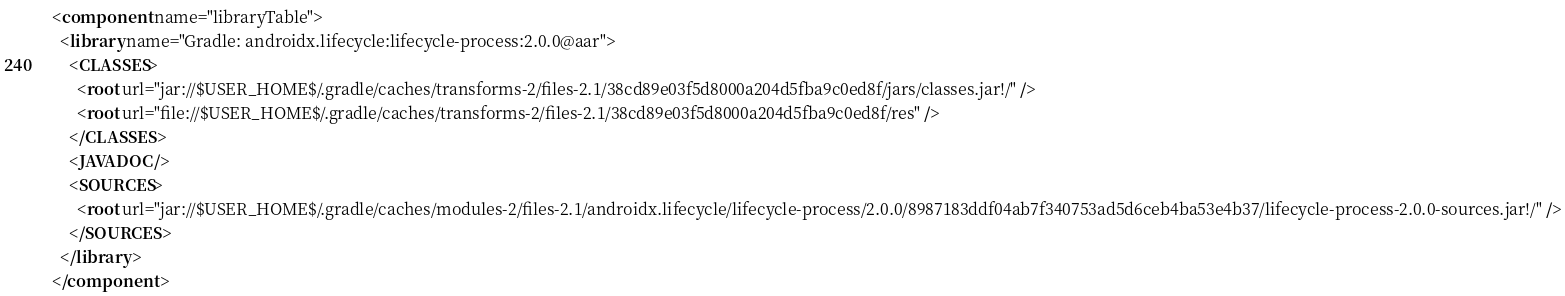Convert code to text. <code><loc_0><loc_0><loc_500><loc_500><_XML_><component name="libraryTable">
  <library name="Gradle: androidx.lifecycle:lifecycle-process:2.0.0@aar">
    <CLASSES>
      <root url="jar://$USER_HOME$/.gradle/caches/transforms-2/files-2.1/38cd89e03f5d8000a204d5fba9c0ed8f/jars/classes.jar!/" />
      <root url="file://$USER_HOME$/.gradle/caches/transforms-2/files-2.1/38cd89e03f5d8000a204d5fba9c0ed8f/res" />
    </CLASSES>
    <JAVADOC />
    <SOURCES>
      <root url="jar://$USER_HOME$/.gradle/caches/modules-2/files-2.1/androidx.lifecycle/lifecycle-process/2.0.0/8987183ddf04ab7f340753ad5d6ceb4ba53e4b37/lifecycle-process-2.0.0-sources.jar!/" />
    </SOURCES>
  </library>
</component></code> 